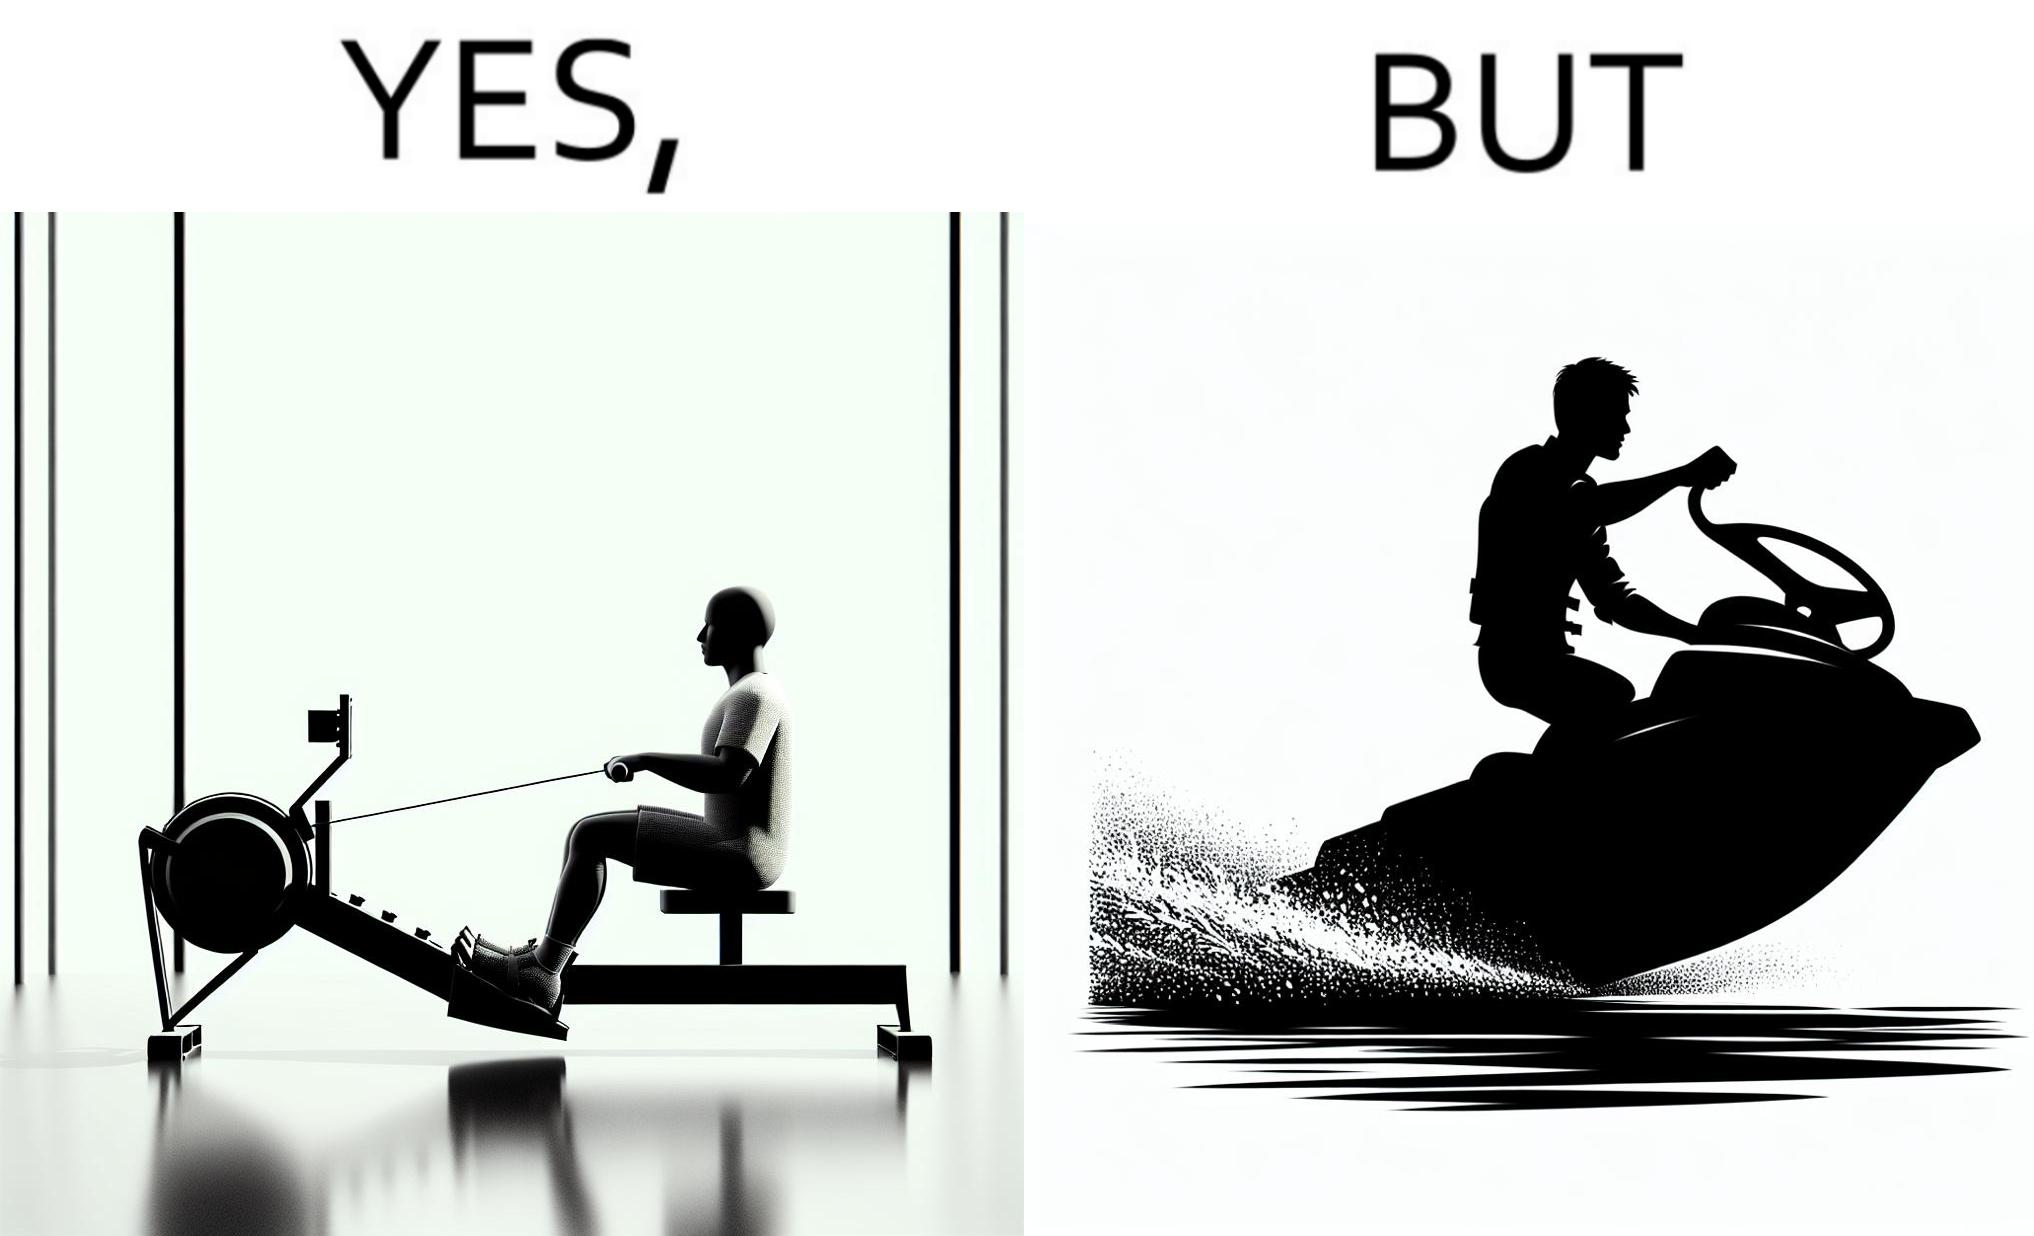What does this image depict? The image is ironic, because people often use rowing machine at the gym don't prefer rowing when it comes to boats 